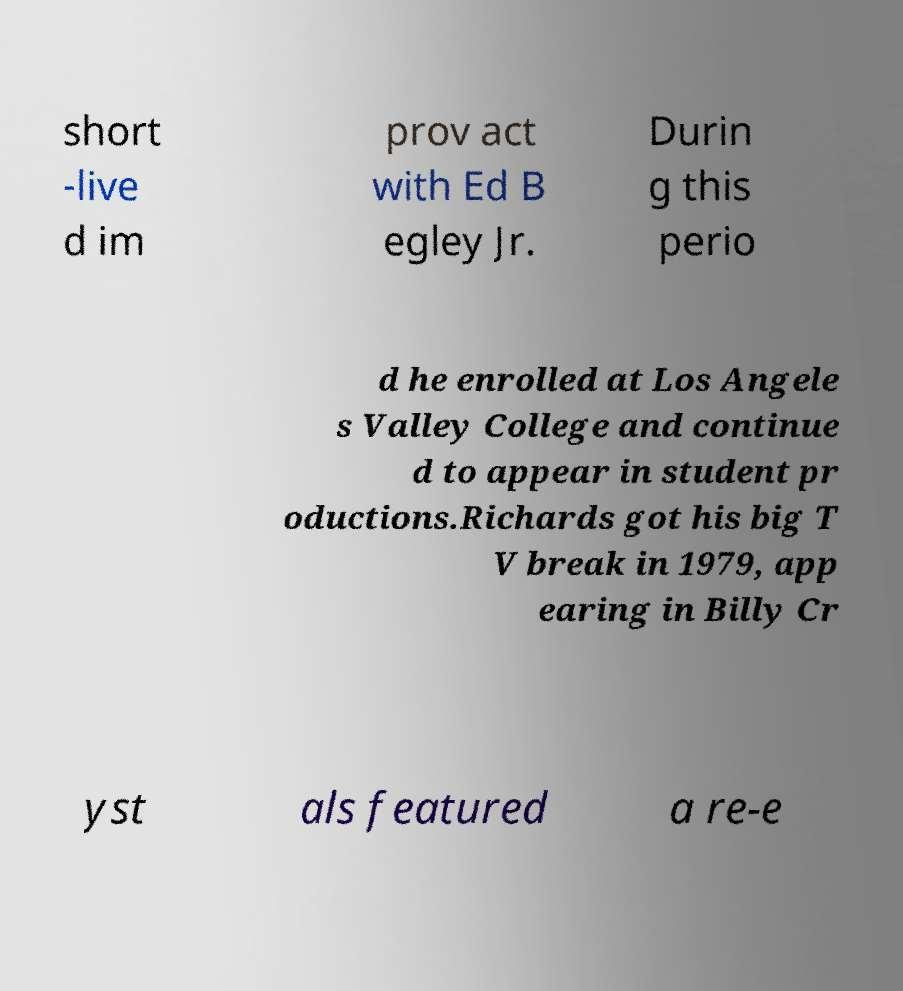Can you read and provide the text displayed in the image?This photo seems to have some interesting text. Can you extract and type it out for me? short -live d im prov act with Ed B egley Jr. Durin g this perio d he enrolled at Los Angele s Valley College and continue d to appear in student pr oductions.Richards got his big T V break in 1979, app earing in Billy Cr yst als featured a re-e 